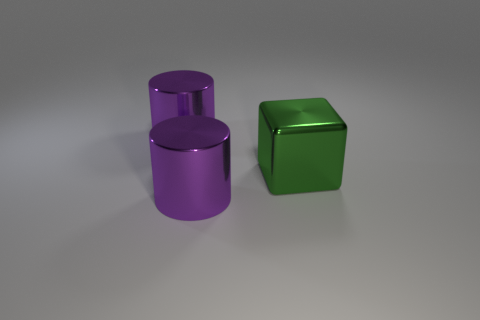Add 2 cubes. How many objects exist? 5 Subtract all cylinders. How many objects are left? 1 Add 3 green rubber blocks. How many green rubber blocks exist? 3 Subtract 0 red balls. How many objects are left? 3 Subtract all metal cylinders. Subtract all big green shiny objects. How many objects are left? 0 Add 1 large purple shiny things. How many large purple shiny things are left? 3 